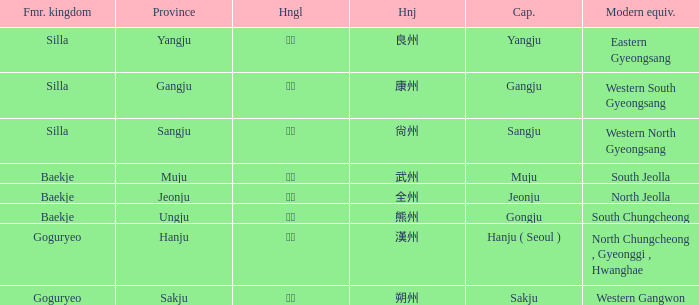The hanja 尙州 is for what capital? Sangju. 